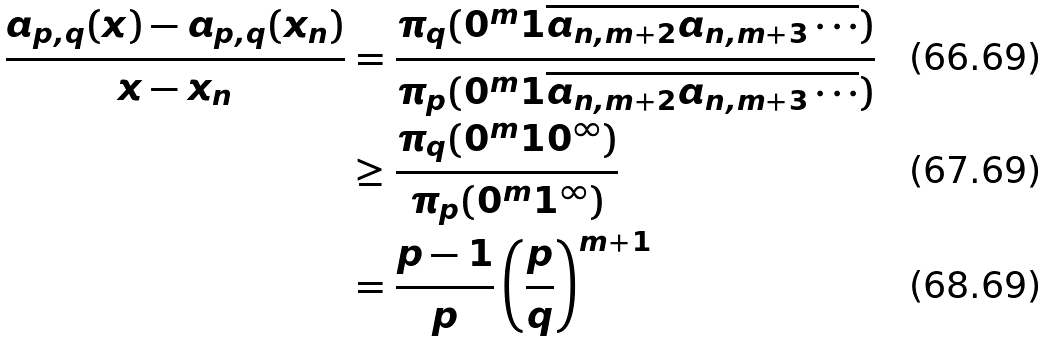Convert formula to latex. <formula><loc_0><loc_0><loc_500><loc_500>\frac { a _ { p , q } ( x ) - a _ { p , q } ( x _ { n } ) } { x - x _ { n } } & = \frac { \pi _ { q } ( 0 ^ { m } 1 \overline { a _ { n , m + 2 } a _ { n , m + 3 } \cdots } ) } { \pi _ { p } ( 0 ^ { m } 1 \overline { a _ { n , m + 2 } a _ { n , m + 3 } \cdots } ) } \\ & \geq \frac { \pi _ { q } ( 0 ^ { m } 1 0 ^ { \infty } ) } { \pi _ { p } ( 0 ^ { m } 1 ^ { \infty } ) } \\ & = \frac { p - 1 } { p } \left ( \frac { p } { q } \right ) ^ { m + 1 }</formula> 